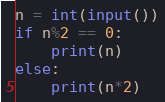Convert code to text. <code><loc_0><loc_0><loc_500><loc_500><_Python_>n = int(input())
if n%2 == 0:
    print(n)
else:
    print(n*2)
</code> 